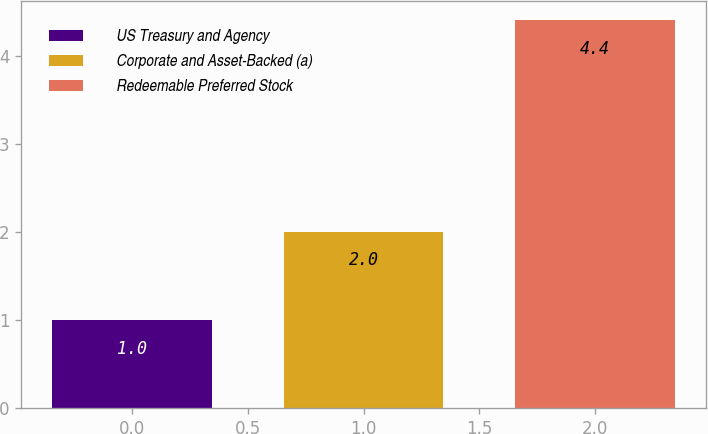Convert chart to OTSL. <chart><loc_0><loc_0><loc_500><loc_500><bar_chart><fcel>US Treasury and Agency<fcel>Corporate and Asset-Backed (a)<fcel>Redeemable Preferred Stock<nl><fcel>1<fcel>2<fcel>4.4<nl></chart> 